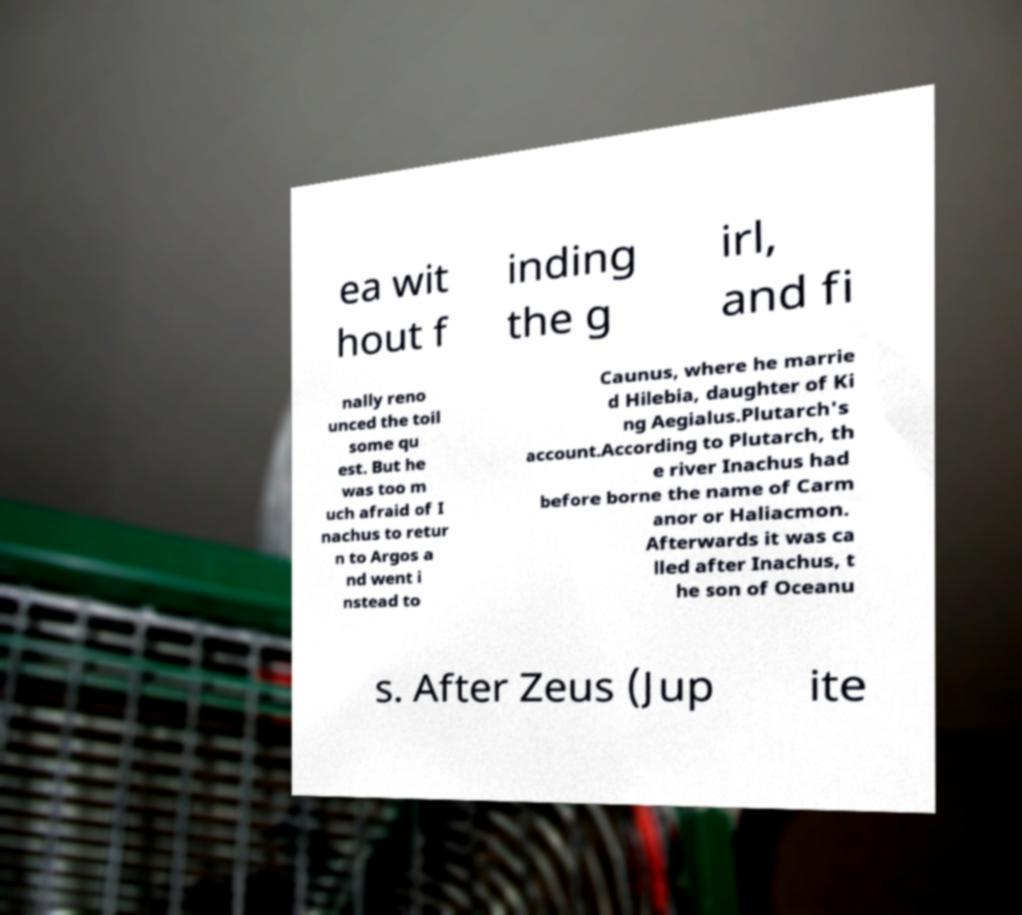What messages or text are displayed in this image? I need them in a readable, typed format. ea wit hout f inding the g irl, and fi nally reno unced the toil some qu est. But he was too m uch afraid of I nachus to retur n to Argos a nd went i nstead to Caunus, where he marrie d Hilebia, daughter of Ki ng Aegialus.Plutarch's account.According to Plutarch, th e river Inachus had before borne the name of Carm anor or Haliacmon. Afterwards it was ca lled after Inachus, t he son of Oceanu s. After Zeus (Jup ite 